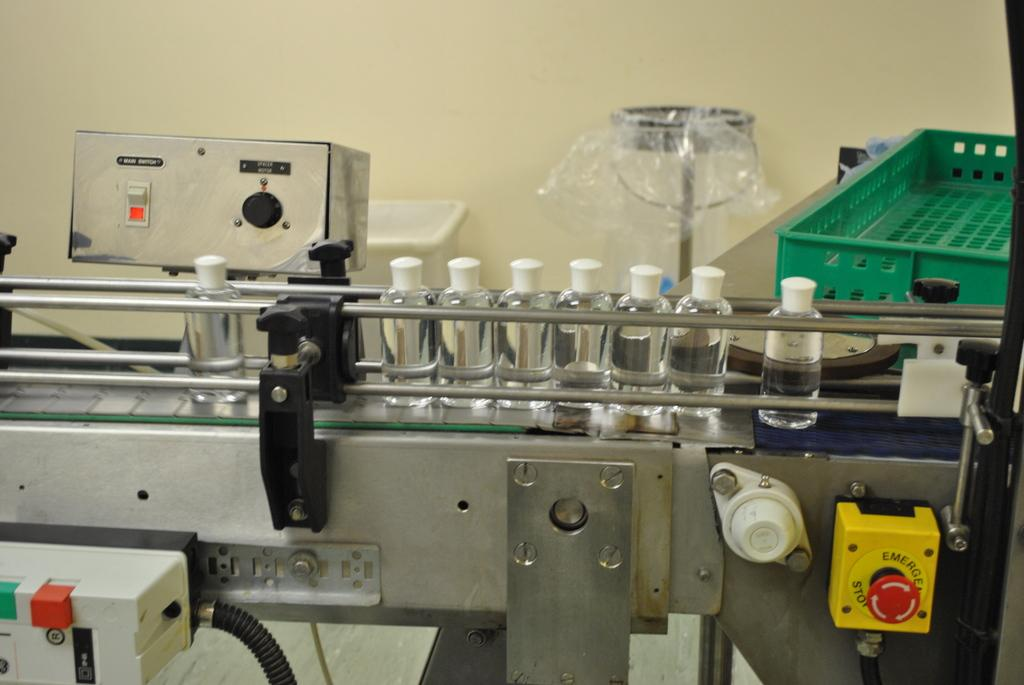What type of equipment can be seen in the image? There is machinery in the image. What is connected to the machinery? There is a belt in the image that is connected to the machinery. What is being transported on the belt? Bottles are placed on the belt. What can be seen in the background of the image? There is a wall in the background of the image. What is used to collect items in the image? There is a bin in the image. What is used to hold items temporarily in the image? There is a tray in the image. What type of skin is being processed in the image? There is no skin or any indication of skin processing in the image; it features machinery, a belt, bottles, a wall, a bin, and a tray. 